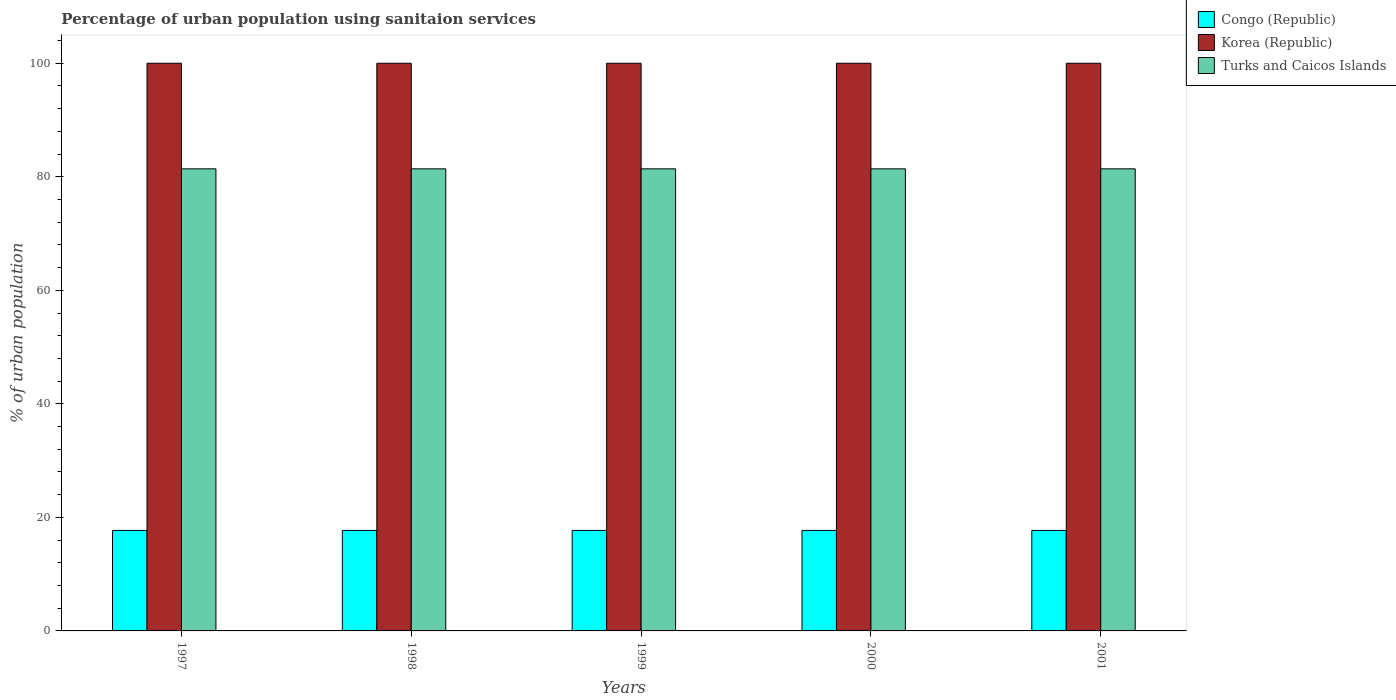How many groups of bars are there?
Offer a terse response. 5. How many bars are there on the 5th tick from the left?
Your answer should be compact. 3. How many bars are there on the 5th tick from the right?
Your answer should be very brief. 3. What is the label of the 5th group of bars from the left?
Make the answer very short. 2001. What is the percentage of urban population using sanitaion services in Congo (Republic) in 2000?
Give a very brief answer. 17.7. Across all years, what is the maximum percentage of urban population using sanitaion services in Korea (Republic)?
Your answer should be very brief. 100. Across all years, what is the minimum percentage of urban population using sanitaion services in Korea (Republic)?
Your response must be concise. 100. In which year was the percentage of urban population using sanitaion services in Korea (Republic) minimum?
Ensure brevity in your answer.  1997. What is the total percentage of urban population using sanitaion services in Turks and Caicos Islands in the graph?
Your response must be concise. 407. What is the difference between the percentage of urban population using sanitaion services in Korea (Republic) in 2000 and the percentage of urban population using sanitaion services in Turks and Caicos Islands in 1998?
Keep it short and to the point. 18.6. What is the average percentage of urban population using sanitaion services in Turks and Caicos Islands per year?
Ensure brevity in your answer.  81.4. In the year 1999, what is the difference between the percentage of urban population using sanitaion services in Korea (Republic) and percentage of urban population using sanitaion services in Turks and Caicos Islands?
Give a very brief answer. 18.6. In how many years, is the percentage of urban population using sanitaion services in Congo (Republic) greater than 76 %?
Your response must be concise. 0. What does the 1st bar from the left in 2000 represents?
Offer a very short reply. Congo (Republic). What does the 3rd bar from the right in 1997 represents?
Your response must be concise. Congo (Republic). Is it the case that in every year, the sum of the percentage of urban population using sanitaion services in Congo (Republic) and percentage of urban population using sanitaion services in Turks and Caicos Islands is greater than the percentage of urban population using sanitaion services in Korea (Republic)?
Make the answer very short. No. How many bars are there?
Offer a very short reply. 15. Are all the bars in the graph horizontal?
Your answer should be compact. No. How many years are there in the graph?
Make the answer very short. 5. What is the difference between two consecutive major ticks on the Y-axis?
Offer a very short reply. 20. Are the values on the major ticks of Y-axis written in scientific E-notation?
Make the answer very short. No. Does the graph contain any zero values?
Your response must be concise. No. Where does the legend appear in the graph?
Keep it short and to the point. Top right. How are the legend labels stacked?
Offer a terse response. Vertical. What is the title of the graph?
Your answer should be very brief. Percentage of urban population using sanitaion services. Does "Tanzania" appear as one of the legend labels in the graph?
Provide a short and direct response. No. What is the label or title of the Y-axis?
Offer a very short reply. % of urban population. What is the % of urban population of Korea (Republic) in 1997?
Ensure brevity in your answer.  100. What is the % of urban population of Turks and Caicos Islands in 1997?
Keep it short and to the point. 81.4. What is the % of urban population in Korea (Republic) in 1998?
Give a very brief answer. 100. What is the % of urban population in Turks and Caicos Islands in 1998?
Make the answer very short. 81.4. What is the % of urban population of Turks and Caicos Islands in 1999?
Make the answer very short. 81.4. What is the % of urban population in Congo (Republic) in 2000?
Provide a succinct answer. 17.7. What is the % of urban population of Turks and Caicos Islands in 2000?
Your response must be concise. 81.4. What is the % of urban population of Congo (Republic) in 2001?
Give a very brief answer. 17.7. What is the % of urban population of Korea (Republic) in 2001?
Offer a terse response. 100. What is the % of urban population of Turks and Caicos Islands in 2001?
Your response must be concise. 81.4. Across all years, what is the maximum % of urban population in Congo (Republic)?
Your answer should be compact. 17.7. Across all years, what is the maximum % of urban population of Turks and Caicos Islands?
Ensure brevity in your answer.  81.4. Across all years, what is the minimum % of urban population of Congo (Republic)?
Keep it short and to the point. 17.7. Across all years, what is the minimum % of urban population of Turks and Caicos Islands?
Your answer should be compact. 81.4. What is the total % of urban population in Congo (Republic) in the graph?
Keep it short and to the point. 88.5. What is the total % of urban population of Turks and Caicos Islands in the graph?
Offer a very short reply. 407. What is the difference between the % of urban population in Korea (Republic) in 1997 and that in 1998?
Provide a short and direct response. 0. What is the difference between the % of urban population of Turks and Caicos Islands in 1997 and that in 1998?
Your response must be concise. 0. What is the difference between the % of urban population in Congo (Republic) in 1997 and that in 1999?
Provide a short and direct response. 0. What is the difference between the % of urban population of Congo (Republic) in 1997 and that in 2000?
Provide a short and direct response. 0. What is the difference between the % of urban population in Korea (Republic) in 1997 and that in 2000?
Offer a very short reply. 0. What is the difference between the % of urban population in Congo (Republic) in 1997 and that in 2001?
Your answer should be compact. 0. What is the difference between the % of urban population of Congo (Republic) in 1998 and that in 2000?
Offer a very short reply. 0. What is the difference between the % of urban population of Korea (Republic) in 1998 and that in 2000?
Offer a terse response. 0. What is the difference between the % of urban population in Congo (Republic) in 1998 and that in 2001?
Keep it short and to the point. 0. What is the difference between the % of urban population in Korea (Republic) in 1998 and that in 2001?
Your response must be concise. 0. What is the difference between the % of urban population in Korea (Republic) in 1999 and that in 2001?
Keep it short and to the point. 0. What is the difference between the % of urban population of Congo (Republic) in 2000 and that in 2001?
Make the answer very short. 0. What is the difference between the % of urban population of Korea (Republic) in 2000 and that in 2001?
Offer a terse response. 0. What is the difference between the % of urban population in Turks and Caicos Islands in 2000 and that in 2001?
Your answer should be compact. 0. What is the difference between the % of urban population of Congo (Republic) in 1997 and the % of urban population of Korea (Republic) in 1998?
Give a very brief answer. -82.3. What is the difference between the % of urban population of Congo (Republic) in 1997 and the % of urban population of Turks and Caicos Islands in 1998?
Keep it short and to the point. -63.7. What is the difference between the % of urban population in Congo (Republic) in 1997 and the % of urban population in Korea (Republic) in 1999?
Offer a terse response. -82.3. What is the difference between the % of urban population of Congo (Republic) in 1997 and the % of urban population of Turks and Caicos Islands in 1999?
Give a very brief answer. -63.7. What is the difference between the % of urban population of Korea (Republic) in 1997 and the % of urban population of Turks and Caicos Islands in 1999?
Your answer should be compact. 18.6. What is the difference between the % of urban population of Congo (Republic) in 1997 and the % of urban population of Korea (Republic) in 2000?
Give a very brief answer. -82.3. What is the difference between the % of urban population of Congo (Republic) in 1997 and the % of urban population of Turks and Caicos Islands in 2000?
Your response must be concise. -63.7. What is the difference between the % of urban population of Korea (Republic) in 1997 and the % of urban population of Turks and Caicos Islands in 2000?
Your response must be concise. 18.6. What is the difference between the % of urban population in Congo (Republic) in 1997 and the % of urban population in Korea (Republic) in 2001?
Give a very brief answer. -82.3. What is the difference between the % of urban population of Congo (Republic) in 1997 and the % of urban population of Turks and Caicos Islands in 2001?
Your answer should be very brief. -63.7. What is the difference between the % of urban population of Korea (Republic) in 1997 and the % of urban population of Turks and Caicos Islands in 2001?
Your answer should be compact. 18.6. What is the difference between the % of urban population in Congo (Republic) in 1998 and the % of urban population in Korea (Republic) in 1999?
Provide a succinct answer. -82.3. What is the difference between the % of urban population of Congo (Republic) in 1998 and the % of urban population of Turks and Caicos Islands in 1999?
Make the answer very short. -63.7. What is the difference between the % of urban population in Congo (Republic) in 1998 and the % of urban population in Korea (Republic) in 2000?
Offer a very short reply. -82.3. What is the difference between the % of urban population in Congo (Republic) in 1998 and the % of urban population in Turks and Caicos Islands in 2000?
Ensure brevity in your answer.  -63.7. What is the difference between the % of urban population of Congo (Republic) in 1998 and the % of urban population of Korea (Republic) in 2001?
Give a very brief answer. -82.3. What is the difference between the % of urban population in Congo (Republic) in 1998 and the % of urban population in Turks and Caicos Islands in 2001?
Offer a terse response. -63.7. What is the difference between the % of urban population of Congo (Republic) in 1999 and the % of urban population of Korea (Republic) in 2000?
Your response must be concise. -82.3. What is the difference between the % of urban population in Congo (Republic) in 1999 and the % of urban population in Turks and Caicos Islands in 2000?
Provide a short and direct response. -63.7. What is the difference between the % of urban population in Korea (Republic) in 1999 and the % of urban population in Turks and Caicos Islands in 2000?
Provide a short and direct response. 18.6. What is the difference between the % of urban population in Congo (Republic) in 1999 and the % of urban population in Korea (Republic) in 2001?
Your answer should be very brief. -82.3. What is the difference between the % of urban population of Congo (Republic) in 1999 and the % of urban population of Turks and Caicos Islands in 2001?
Provide a succinct answer. -63.7. What is the difference between the % of urban population of Congo (Republic) in 2000 and the % of urban population of Korea (Republic) in 2001?
Ensure brevity in your answer.  -82.3. What is the difference between the % of urban population of Congo (Republic) in 2000 and the % of urban population of Turks and Caicos Islands in 2001?
Ensure brevity in your answer.  -63.7. What is the average % of urban population in Korea (Republic) per year?
Give a very brief answer. 100. What is the average % of urban population in Turks and Caicos Islands per year?
Your response must be concise. 81.4. In the year 1997, what is the difference between the % of urban population in Congo (Republic) and % of urban population in Korea (Republic)?
Provide a succinct answer. -82.3. In the year 1997, what is the difference between the % of urban population of Congo (Republic) and % of urban population of Turks and Caicos Islands?
Keep it short and to the point. -63.7. In the year 1998, what is the difference between the % of urban population in Congo (Republic) and % of urban population in Korea (Republic)?
Offer a terse response. -82.3. In the year 1998, what is the difference between the % of urban population of Congo (Republic) and % of urban population of Turks and Caicos Islands?
Your response must be concise. -63.7. In the year 1998, what is the difference between the % of urban population of Korea (Republic) and % of urban population of Turks and Caicos Islands?
Your response must be concise. 18.6. In the year 1999, what is the difference between the % of urban population in Congo (Republic) and % of urban population in Korea (Republic)?
Keep it short and to the point. -82.3. In the year 1999, what is the difference between the % of urban population in Congo (Republic) and % of urban population in Turks and Caicos Islands?
Ensure brevity in your answer.  -63.7. In the year 2000, what is the difference between the % of urban population of Congo (Republic) and % of urban population of Korea (Republic)?
Your answer should be compact. -82.3. In the year 2000, what is the difference between the % of urban population in Congo (Republic) and % of urban population in Turks and Caicos Islands?
Make the answer very short. -63.7. In the year 2000, what is the difference between the % of urban population in Korea (Republic) and % of urban population in Turks and Caicos Islands?
Ensure brevity in your answer.  18.6. In the year 2001, what is the difference between the % of urban population of Congo (Republic) and % of urban population of Korea (Republic)?
Your answer should be very brief. -82.3. In the year 2001, what is the difference between the % of urban population in Congo (Republic) and % of urban population in Turks and Caicos Islands?
Provide a succinct answer. -63.7. What is the ratio of the % of urban population in Korea (Republic) in 1997 to that in 1998?
Offer a terse response. 1. What is the ratio of the % of urban population in Turks and Caicos Islands in 1997 to that in 1998?
Offer a very short reply. 1. What is the ratio of the % of urban population of Korea (Republic) in 1997 to that in 1999?
Make the answer very short. 1. What is the ratio of the % of urban population in Turks and Caicos Islands in 1997 to that in 1999?
Provide a succinct answer. 1. What is the ratio of the % of urban population of Congo (Republic) in 1997 to that in 2000?
Your answer should be very brief. 1. What is the ratio of the % of urban population in Congo (Republic) in 1997 to that in 2001?
Your answer should be very brief. 1. What is the ratio of the % of urban population in Korea (Republic) in 1997 to that in 2001?
Offer a terse response. 1. What is the ratio of the % of urban population in Turks and Caicos Islands in 1997 to that in 2001?
Your response must be concise. 1. What is the ratio of the % of urban population of Congo (Republic) in 1998 to that in 1999?
Your response must be concise. 1. What is the ratio of the % of urban population of Turks and Caicos Islands in 1998 to that in 1999?
Make the answer very short. 1. What is the ratio of the % of urban population in Congo (Republic) in 1998 to that in 2000?
Your answer should be compact. 1. What is the ratio of the % of urban population in Korea (Republic) in 1998 to that in 2000?
Provide a short and direct response. 1. What is the ratio of the % of urban population in Korea (Republic) in 1998 to that in 2001?
Provide a succinct answer. 1. What is the ratio of the % of urban population of Turks and Caicos Islands in 1999 to that in 2000?
Your response must be concise. 1. What is the difference between the highest and the lowest % of urban population of Congo (Republic)?
Provide a succinct answer. 0. What is the difference between the highest and the lowest % of urban population in Korea (Republic)?
Keep it short and to the point. 0. What is the difference between the highest and the lowest % of urban population in Turks and Caicos Islands?
Provide a short and direct response. 0. 